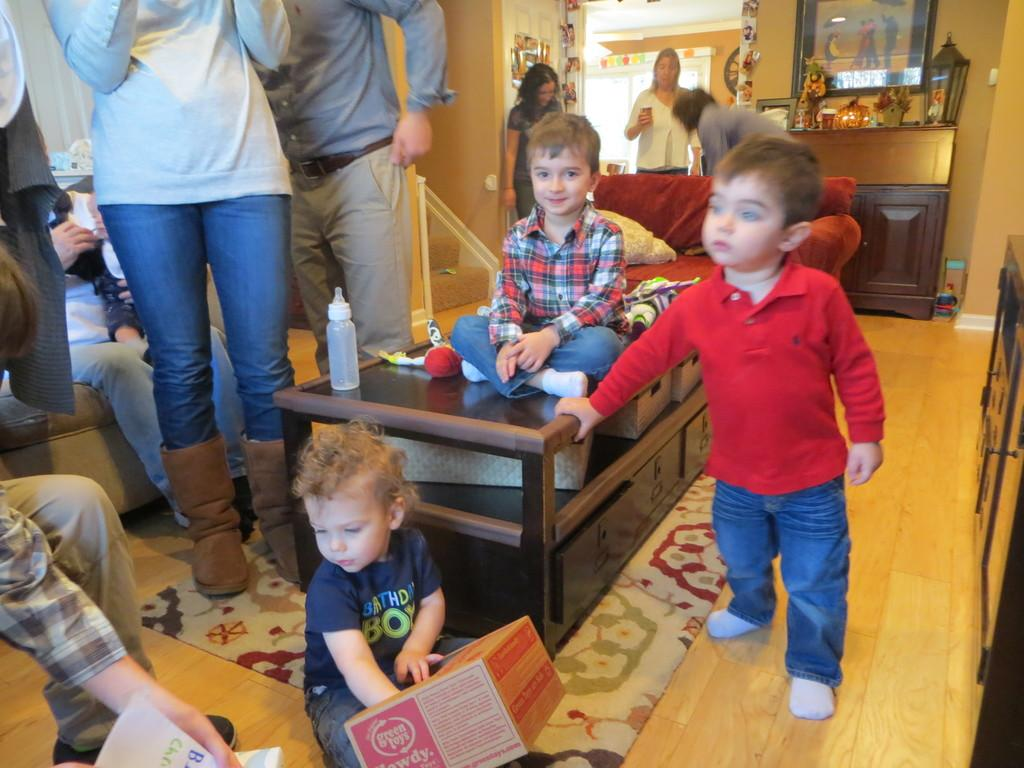How many people are in the image? There are multiple people in the image. What are the people in the image doing? Some people are sitting, while others are standing. Can you describe the child in the image? The child is in the image and is holding a box. What is the name of the dog in the image? There is no dog present in the image. What is the child writing on the box? The image does not show the child writing on the box; the child is simply holding it. 